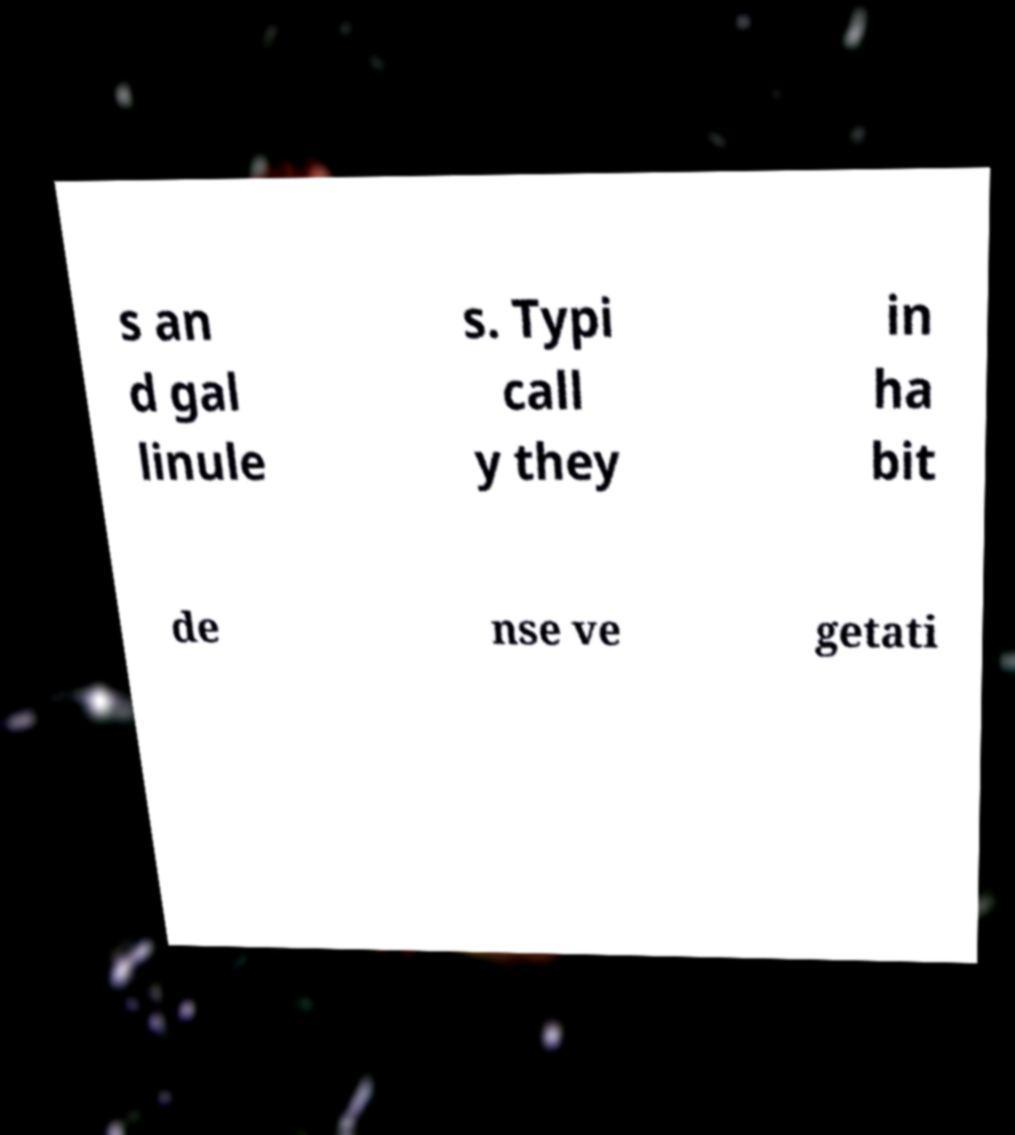I need the written content from this picture converted into text. Can you do that? s an d gal linule s. Typi call y they in ha bit de nse ve getati 